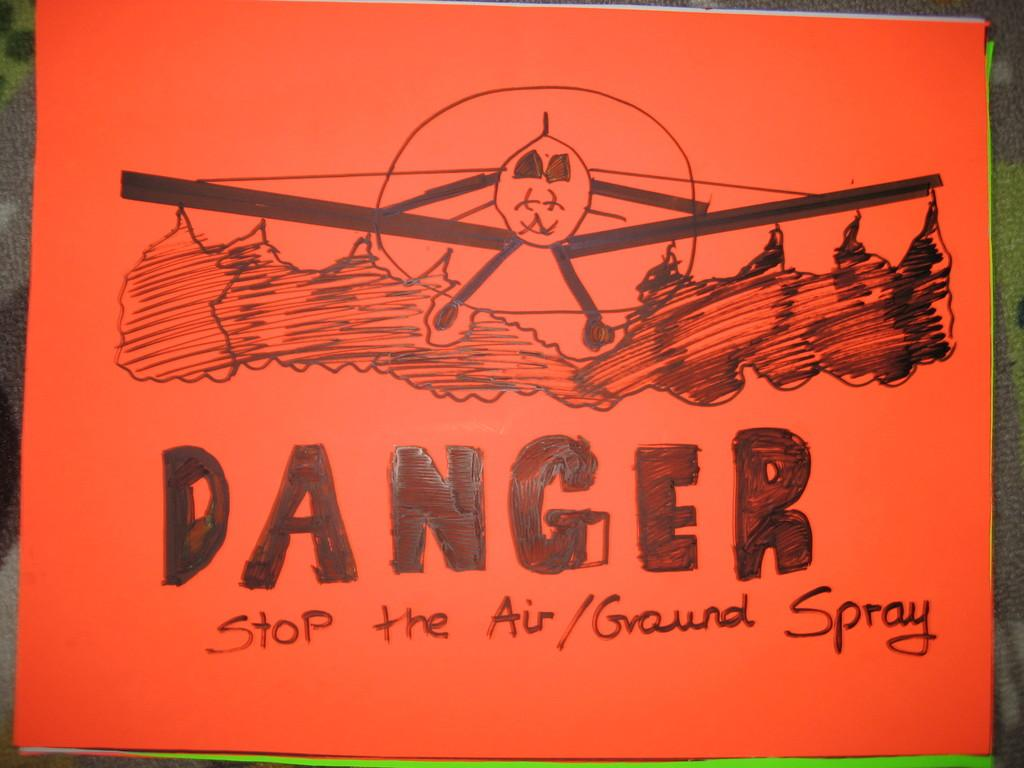<image>
Render a clear and concise summary of the photo. A hand draw poster bears a picture of an aeroplane spraying the ground with the word Danger writ large below it. 